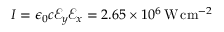<formula> <loc_0><loc_0><loc_500><loc_500>I = \epsilon _ { 0 } c \mathcal { E } _ { y } \mathcal { E } _ { x } = 2 . 6 5 \times 1 0 ^ { 6 } \, W \, c m ^ { - 2 }</formula> 